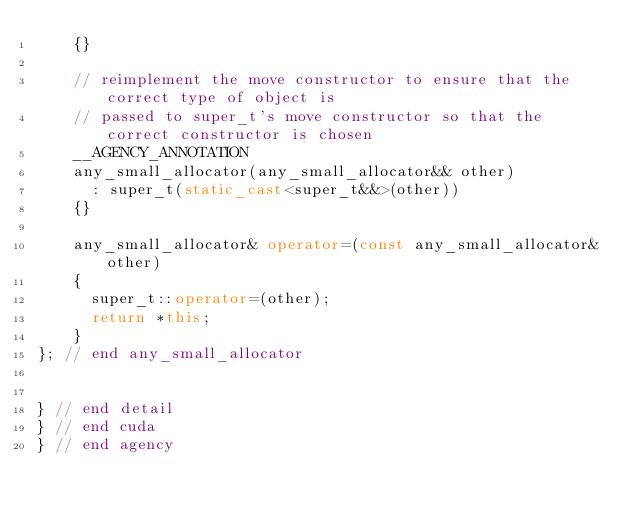Convert code to text. <code><loc_0><loc_0><loc_500><loc_500><_C++_>    {}

    // reimplement the move constructor to ensure that the correct type of object is
    // passed to super_t's move constructor so that the correct constructor is chosen
    __AGENCY_ANNOTATION
    any_small_allocator(any_small_allocator&& other)
      : super_t(static_cast<super_t&&>(other))
    {}

    any_small_allocator& operator=(const any_small_allocator& other)
    {
      super_t::operator=(other);
      return *this;
    }
}; // end any_small_allocator


} // end detail
} // end cuda
} // end agency

</code> 